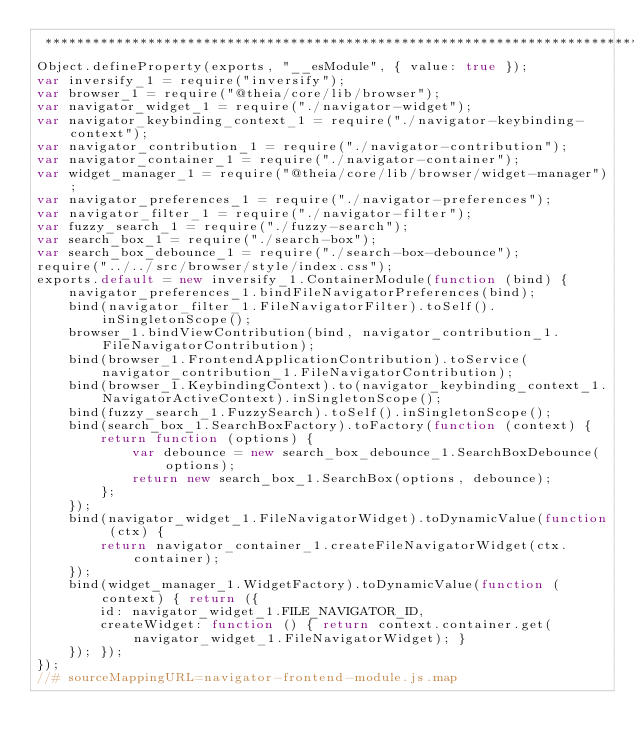<code> <loc_0><loc_0><loc_500><loc_500><_JavaScript_> ********************************************************************************/
Object.defineProperty(exports, "__esModule", { value: true });
var inversify_1 = require("inversify");
var browser_1 = require("@theia/core/lib/browser");
var navigator_widget_1 = require("./navigator-widget");
var navigator_keybinding_context_1 = require("./navigator-keybinding-context");
var navigator_contribution_1 = require("./navigator-contribution");
var navigator_container_1 = require("./navigator-container");
var widget_manager_1 = require("@theia/core/lib/browser/widget-manager");
var navigator_preferences_1 = require("./navigator-preferences");
var navigator_filter_1 = require("./navigator-filter");
var fuzzy_search_1 = require("./fuzzy-search");
var search_box_1 = require("./search-box");
var search_box_debounce_1 = require("./search-box-debounce");
require("../../src/browser/style/index.css");
exports.default = new inversify_1.ContainerModule(function (bind) {
    navigator_preferences_1.bindFileNavigatorPreferences(bind);
    bind(navigator_filter_1.FileNavigatorFilter).toSelf().inSingletonScope();
    browser_1.bindViewContribution(bind, navigator_contribution_1.FileNavigatorContribution);
    bind(browser_1.FrontendApplicationContribution).toService(navigator_contribution_1.FileNavigatorContribution);
    bind(browser_1.KeybindingContext).to(navigator_keybinding_context_1.NavigatorActiveContext).inSingletonScope();
    bind(fuzzy_search_1.FuzzySearch).toSelf().inSingletonScope();
    bind(search_box_1.SearchBoxFactory).toFactory(function (context) {
        return function (options) {
            var debounce = new search_box_debounce_1.SearchBoxDebounce(options);
            return new search_box_1.SearchBox(options, debounce);
        };
    });
    bind(navigator_widget_1.FileNavigatorWidget).toDynamicValue(function (ctx) {
        return navigator_container_1.createFileNavigatorWidget(ctx.container);
    });
    bind(widget_manager_1.WidgetFactory).toDynamicValue(function (context) { return ({
        id: navigator_widget_1.FILE_NAVIGATOR_ID,
        createWidget: function () { return context.container.get(navigator_widget_1.FileNavigatorWidget); }
    }); });
});
//# sourceMappingURL=navigator-frontend-module.js.map</code> 